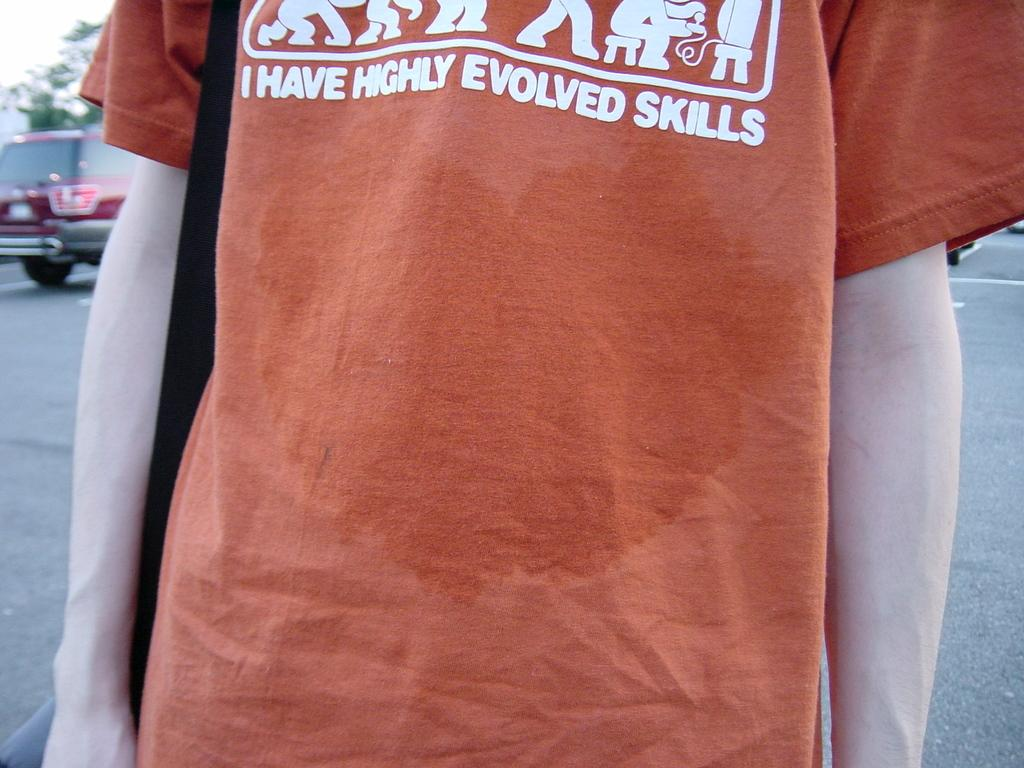Provide a one-sentence caption for the provided image. A wet orange shirt saying the person has highly evolved skills. 